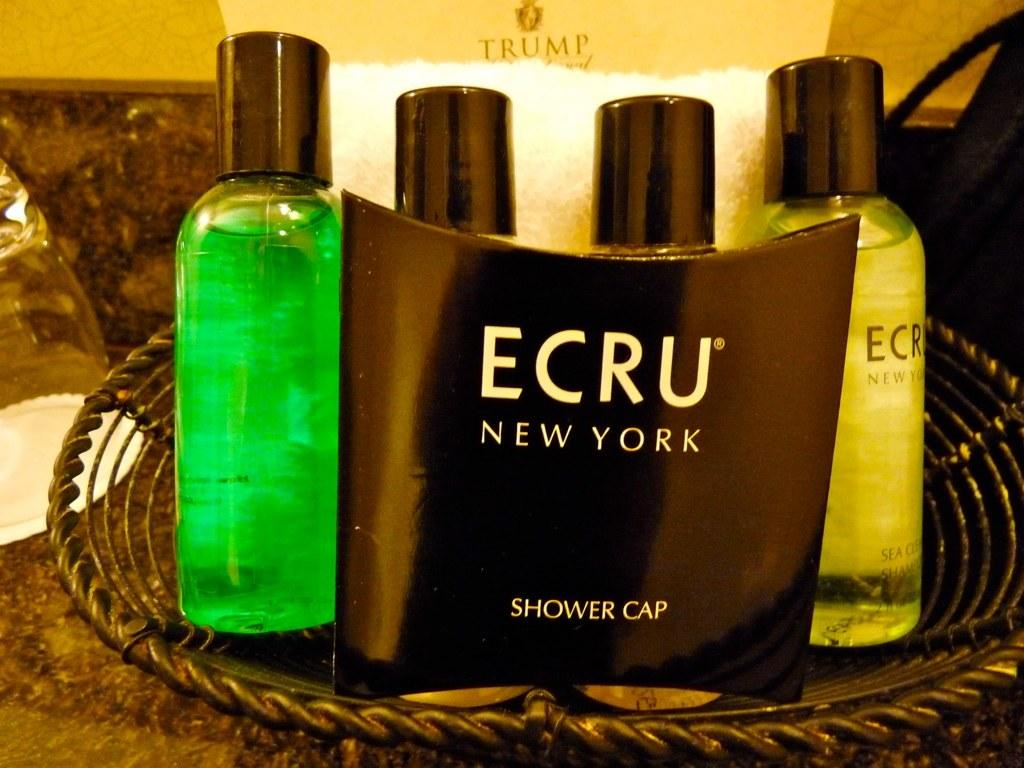What type of objects are present in the image? There are perfume bottles in the image. Can you describe the appearance of the perfume bottles? The perfume bottles have different colors. How many trains are visible in the image? There are no trains present in the image; it features perfume bottles with different colors. 